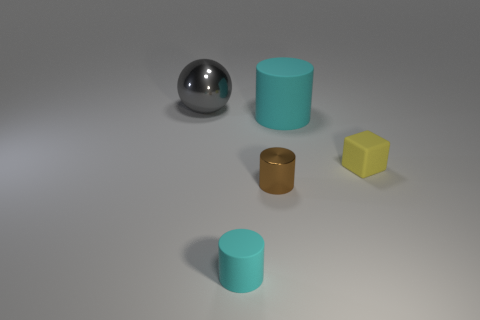There is a cyan thing in front of the tiny brown thing; what number of tiny cylinders are in front of it?
Keep it short and to the point. 0. How many other things are there of the same size as the metal sphere?
Your answer should be very brief. 1. What number of things are either tiny gray rubber balls or cylinders in front of the sphere?
Offer a terse response. 3. Is the number of tiny yellow blocks less than the number of big objects?
Your response must be concise. Yes. There is a metallic thing that is in front of the matte thing to the right of the big rubber cylinder; what is its color?
Offer a terse response. Brown. There is a small cyan object that is the same shape as the tiny brown thing; what is it made of?
Ensure brevity in your answer.  Rubber. How many metal things are large green cylinders or yellow blocks?
Offer a very short reply. 0. Do the block to the right of the brown shiny cylinder and the big thing left of the brown cylinder have the same material?
Your answer should be very brief. No. Is there a tiny gray rubber thing?
Your response must be concise. No. There is a cyan object that is left of the small brown shiny thing; does it have the same shape as the cyan object that is behind the tiny cube?
Provide a succinct answer. Yes. 